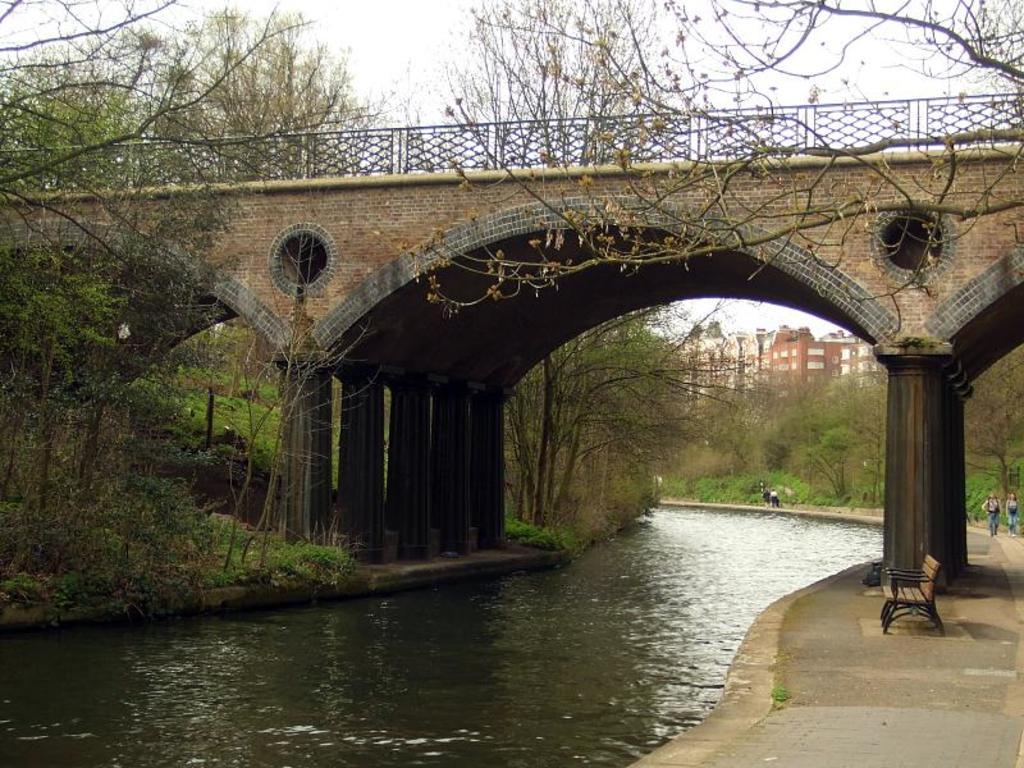What is located on the ground in the image? There is a bench on the ground in the image. How many people are present in the image? There are two people in the image. What can be seen in the image besides the bench and people? There is water, a bridge, trees, buildings, and the sky visible in the image. What reason do the boys have for sitting at the desk in the image? There are no boys or desks present in the image, so there is no reason to discuss. 